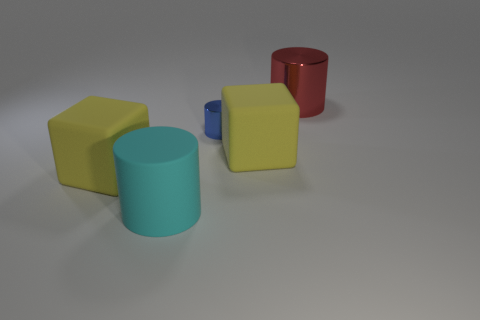Add 1 large red objects. How many objects exist? 6 Subtract all cylinders. How many objects are left? 2 Subtract 0 gray blocks. How many objects are left? 5 Subtract all small purple objects. Subtract all tiny metal cylinders. How many objects are left? 4 Add 5 cyan matte objects. How many cyan matte objects are left? 6 Add 4 large matte cylinders. How many large matte cylinders exist? 5 